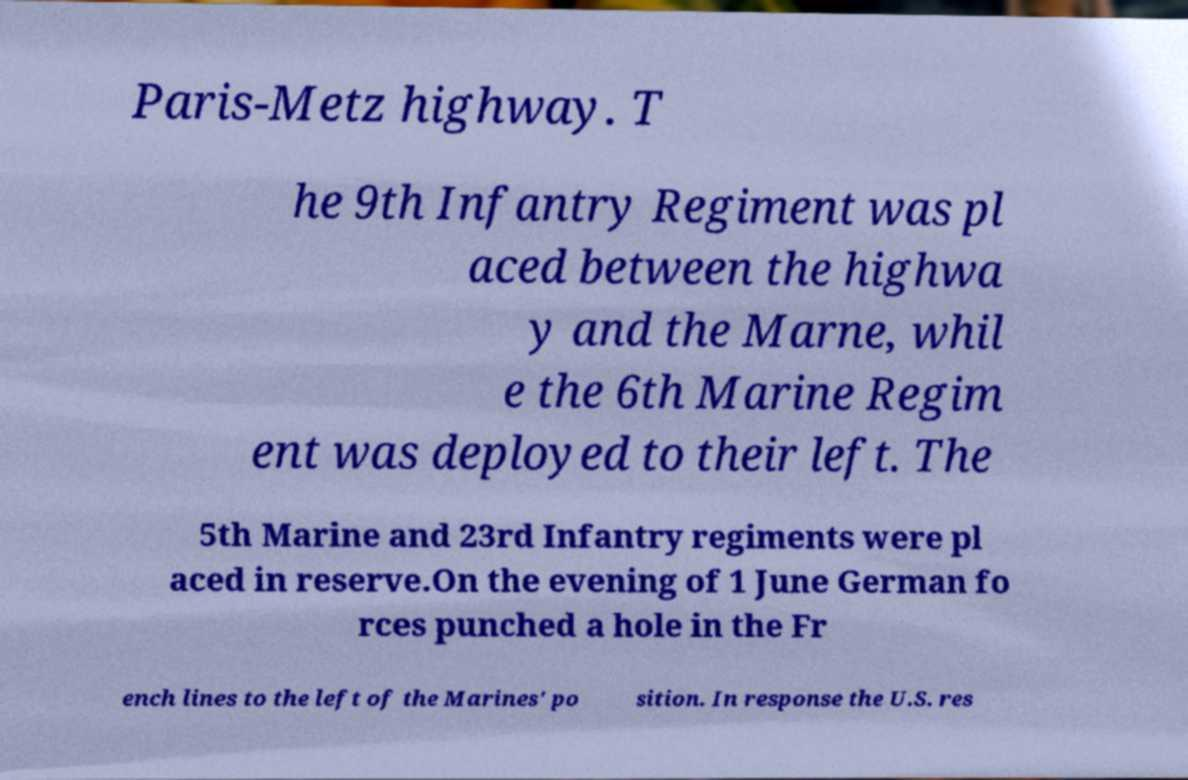Can you read and provide the text displayed in the image?This photo seems to have some interesting text. Can you extract and type it out for me? Paris-Metz highway. T he 9th Infantry Regiment was pl aced between the highwa y and the Marne, whil e the 6th Marine Regim ent was deployed to their left. The 5th Marine and 23rd Infantry regiments were pl aced in reserve.On the evening of 1 June German fo rces punched a hole in the Fr ench lines to the left of the Marines' po sition. In response the U.S. res 